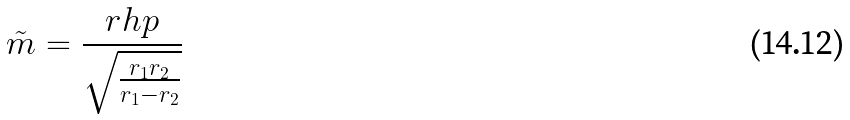Convert formula to latex. <formula><loc_0><loc_0><loc_500><loc_500>\tilde { m } = \frac { r h p } { \sqrt { \frac { r _ { 1 } r _ { 2 } } { r _ { 1 } - r _ { 2 } } } }</formula> 